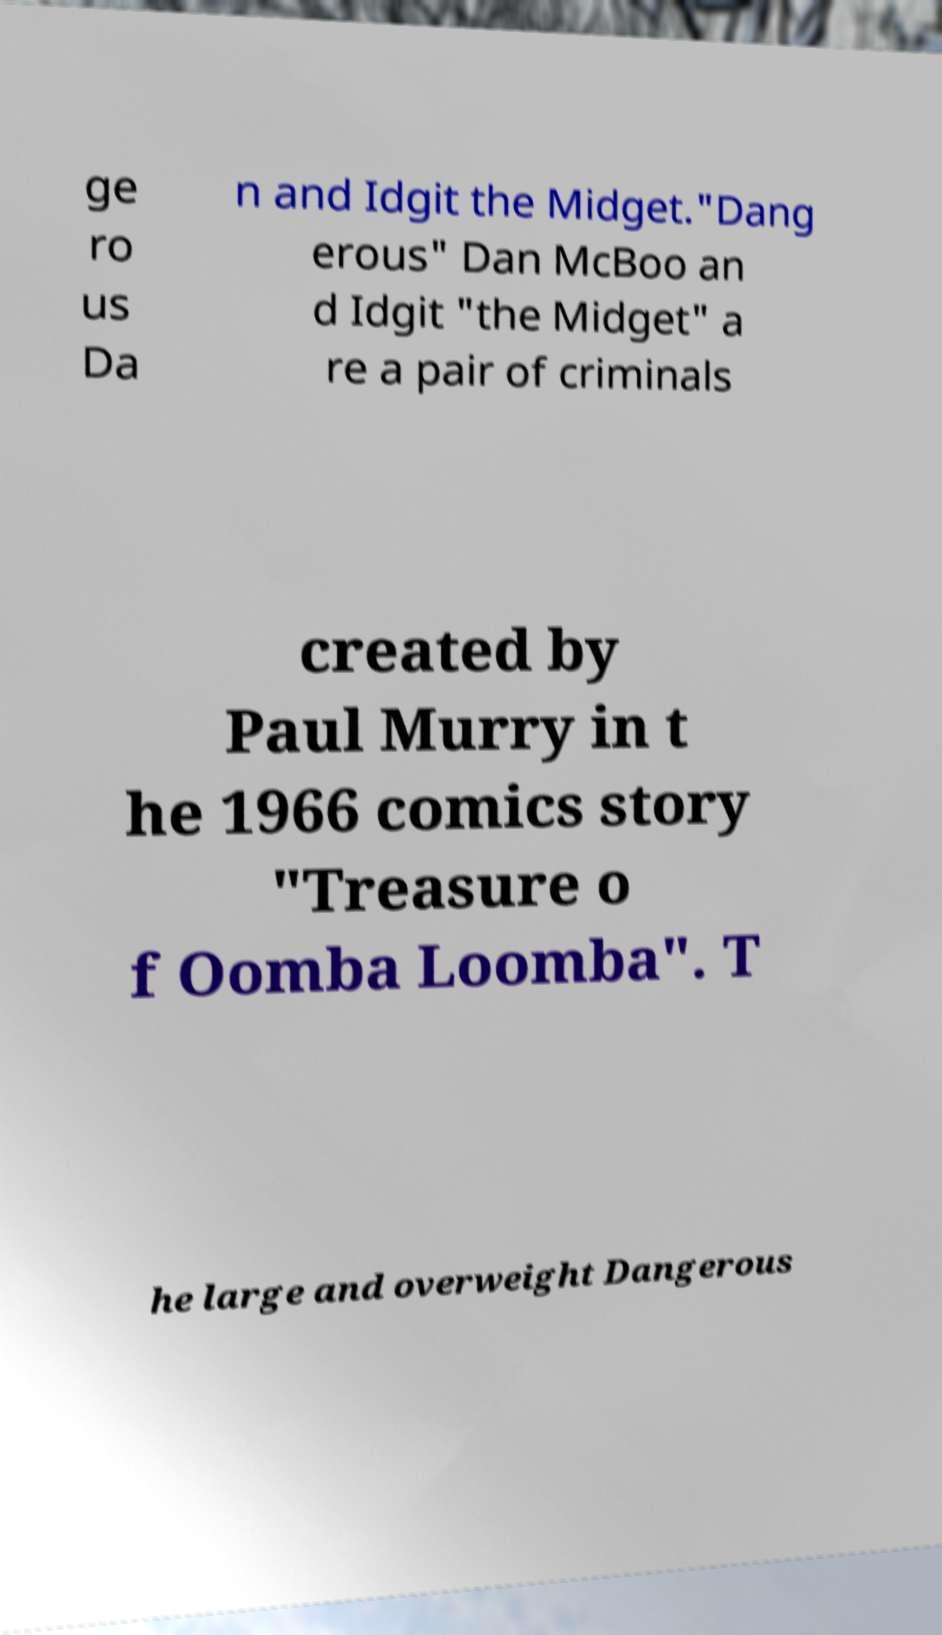Could you assist in decoding the text presented in this image and type it out clearly? ge ro us Da n and Idgit the Midget."Dang erous" Dan McBoo an d Idgit "the Midget" a re a pair of criminals created by Paul Murry in t he 1966 comics story "Treasure o f Oomba Loomba". T he large and overweight Dangerous 